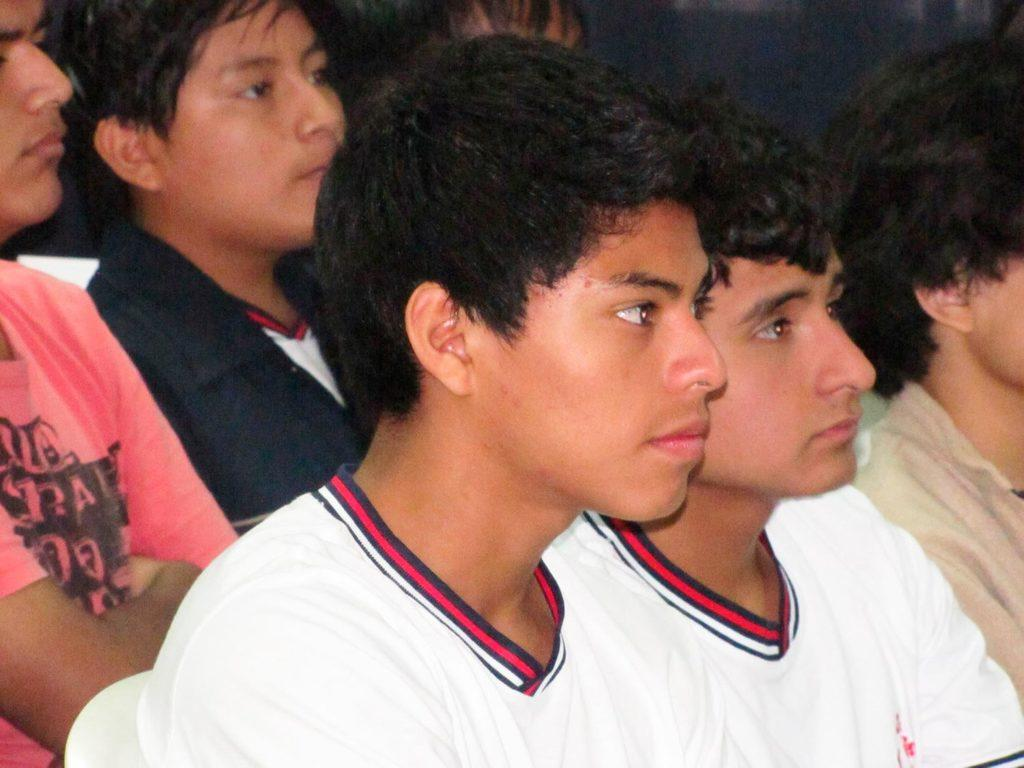Who or what can be seen in the image? There are people in the image. What are the people doing in the image? The people are sitting on chairs. What type of sleet can be seen falling on the people in the image? There is no sleet present in the image; it only shows people sitting on chairs. What color is the nose of the person sitting on the left chair in the image? There is no information about the color of anyone's nose in the image, as it only shows people sitting on chairs. 